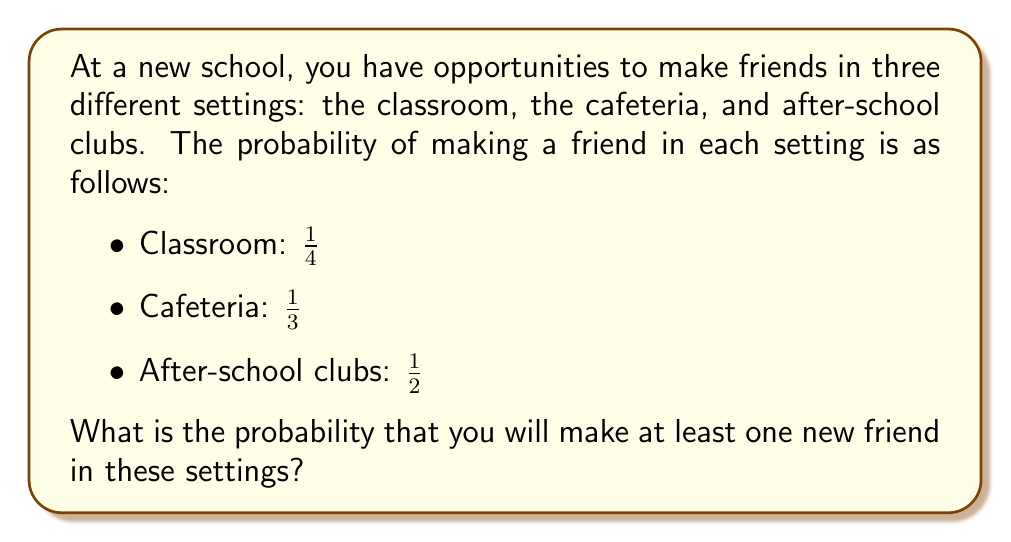Teach me how to tackle this problem. Let's approach this step-by-step:

1) First, we need to find the probability of not making a friend in each setting:
   - Classroom: $1 - \frac{1}{4} = \frac{3}{4}$
   - Cafeteria: $1 - \frac{1}{3} = \frac{2}{3}$
   - After-school clubs: $1 - \frac{1}{2} = \frac{1}{2}$

2) The probability of not making a friend in any of these settings is the product of these probabilities:

   $$P(\text{no friends}) = \frac{3}{4} \cdot \frac{2}{3} \cdot \frac{1}{2} = \frac{1}{4}$$

3) Therefore, the probability of making at least one friend is the complement of this probability:

   $$P(\text{at least one friend}) = 1 - P(\text{no friends}) = 1 - \frac{1}{4} = \frac{3}{4}$$

4) We can convert this to a percentage:

   $$\frac{3}{4} = 0.75 = 75\%$$

Thus, there is a 75% chance of making at least one new friend in these settings.
Answer: $\frac{3}{4}$ or 75% 